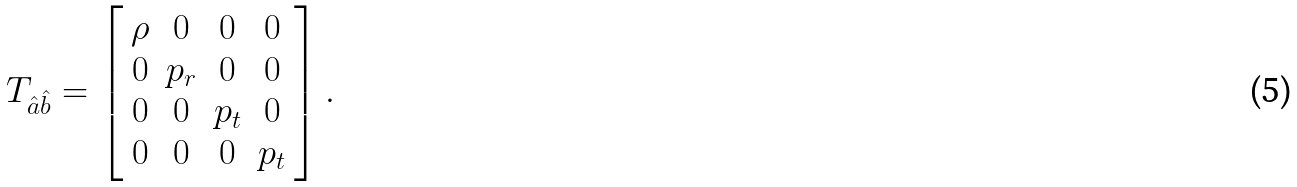Convert formula to latex. <formula><loc_0><loc_0><loc_500><loc_500>T _ { \hat { a } \hat { b } } = \left [ \begin{array} { c c c c } \rho & 0 & 0 & 0 \\ 0 & p _ { r } & 0 & 0 \\ 0 & 0 & p _ { t } & 0 \\ 0 & 0 & 0 & p _ { t } \end{array} \right ] .</formula> 